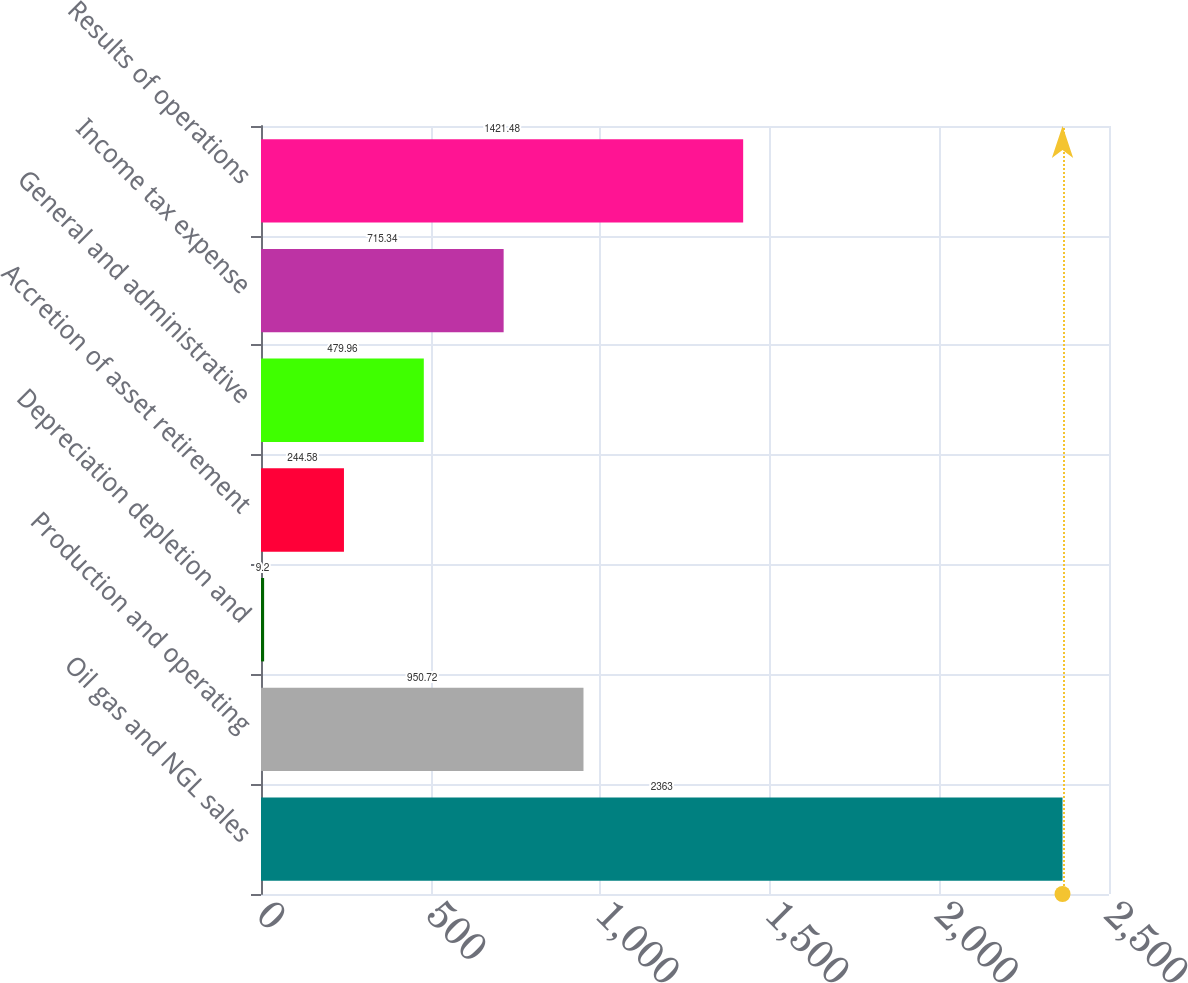Convert chart. <chart><loc_0><loc_0><loc_500><loc_500><bar_chart><fcel>Oil gas and NGL sales<fcel>Production and operating<fcel>Depreciation depletion and<fcel>Accretion of asset retirement<fcel>General and administrative<fcel>Income tax expense<fcel>Results of operations<nl><fcel>2363<fcel>950.72<fcel>9.2<fcel>244.58<fcel>479.96<fcel>715.34<fcel>1421.48<nl></chart> 